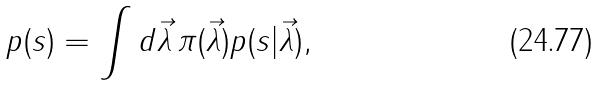<formula> <loc_0><loc_0><loc_500><loc_500>p ( s ) = \int d \vec { \lambda } \, \pi ( \vec { \lambda } ) p ( s | \vec { \lambda } ) ,</formula> 